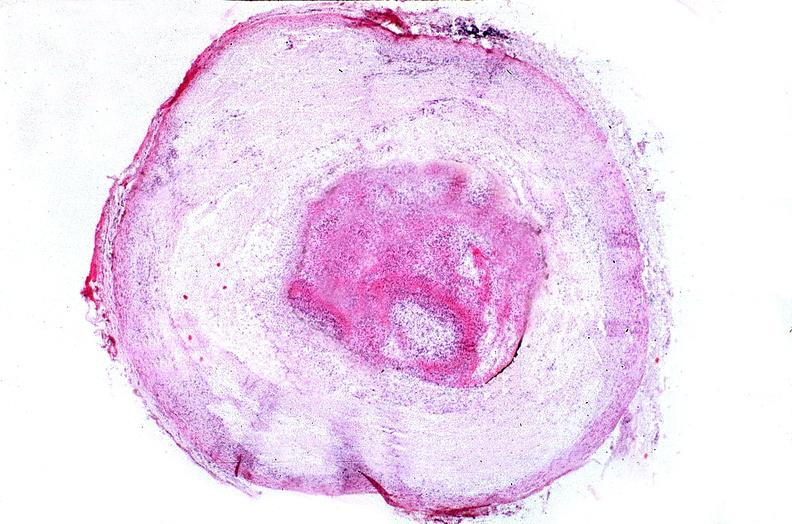does anencephaly show coronary artery with atherosclerosis and thrombotic occlusion?
Answer the question using a single word or phrase. No 